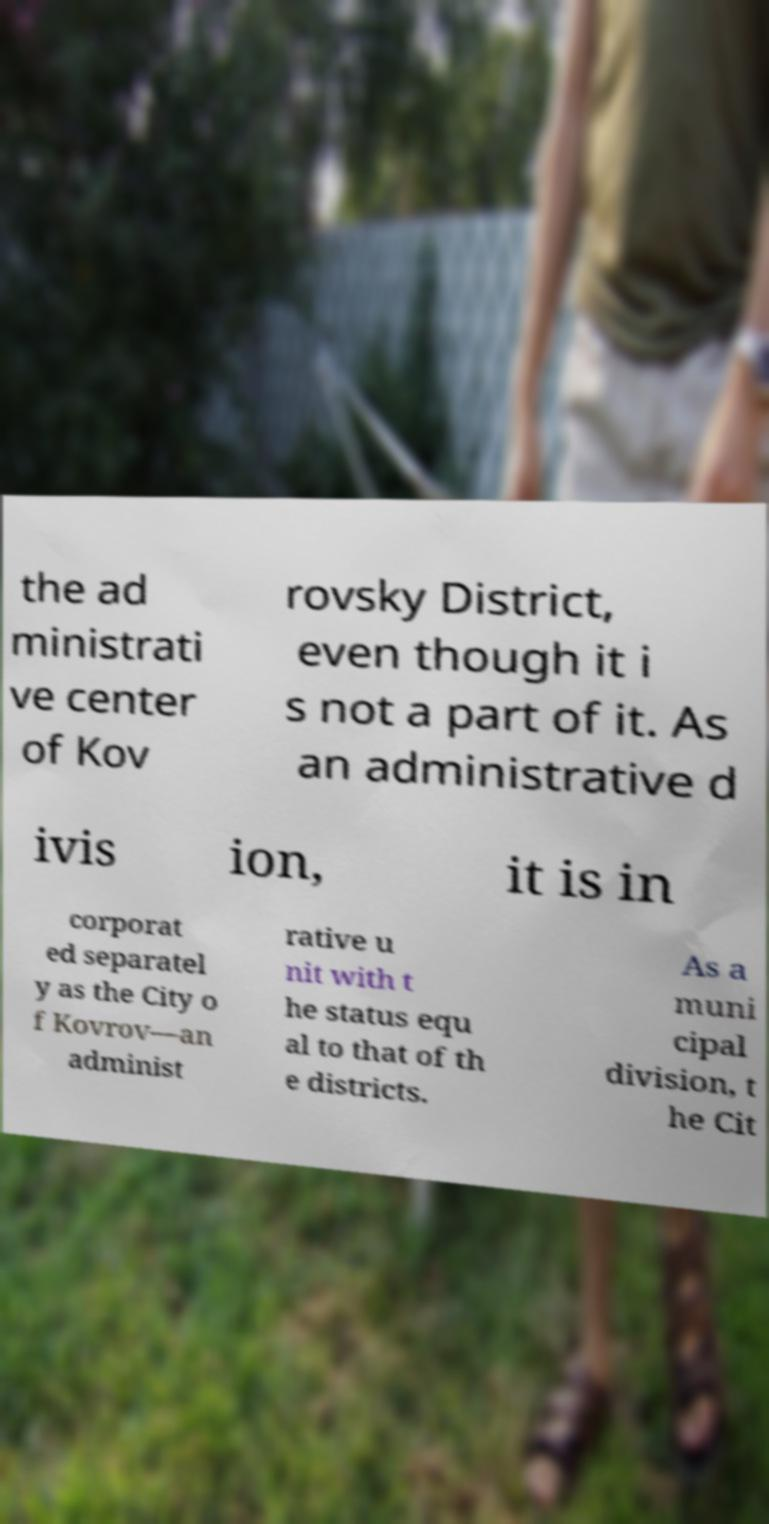There's text embedded in this image that I need extracted. Can you transcribe it verbatim? the ad ministrati ve center of Kov rovsky District, even though it i s not a part of it. As an administrative d ivis ion, it is in corporat ed separatel y as the City o f Kovrov—an administ rative u nit with t he status equ al to that of th e districts. As a muni cipal division, t he Cit 